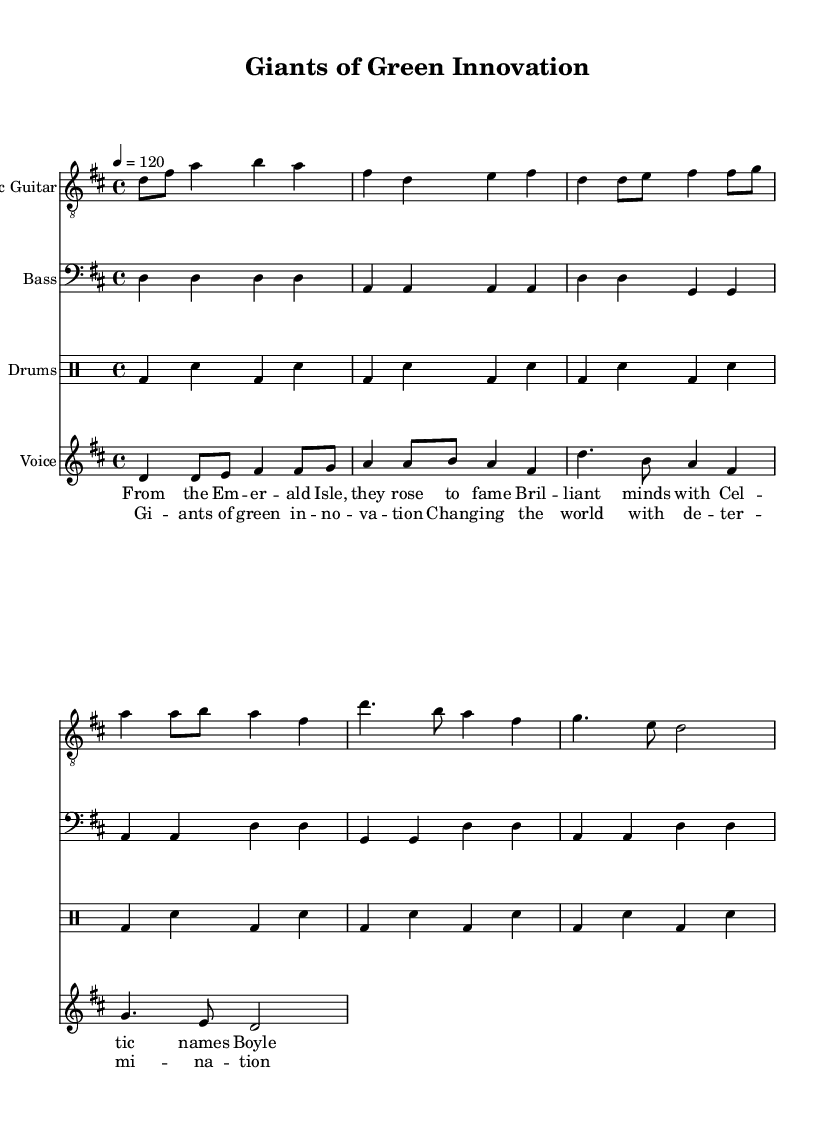What is the key signature of this music? The key signature appears at the beginning of the staff, indicating two sharps (F# and C#), which means it is in D major.
Answer: D major What is the time signature of this piece? The time signature is found right after the key signature, presented as 4/4, indicating four beats in each measure with a quarter note receiving one beat.
Answer: 4/4 What is the tempo marking of the song? The tempo marking is indicated at the beginning of the score, showing a metronome mark of 120 beats per minute, meaning the song is set to a moderately fast pace.
Answer: 120 How many measures are there in the electric guitar part? By counting the individual measures within the electric guitar notation section, there are a total of 12 measures in the part scored for electric guitar.
Answer: 12 What is the main lyrical theme of the song? The lyrics reflect the contributions of Irish scientists, highlighted by references to prominent figures such as Boyle and Hamilton, emphasizing themes of innovation and recognition.
Answer: Innovation What role do the drums play in this composition? The drum part is consistent, maintaining a steady backbeat throughout the piece, emphasizing the rhythm without changing, which supports the rock genre's energetic feel.
Answer: Steady backbeat What is the function of the bass guitar in this piece? The bass guitar provides foundational support for the harmonic framework, playing root notes that anchor the chords defined by the electric guitar, contributing to the overall rhythmic drive of the piece.
Answer: Harmonic support 